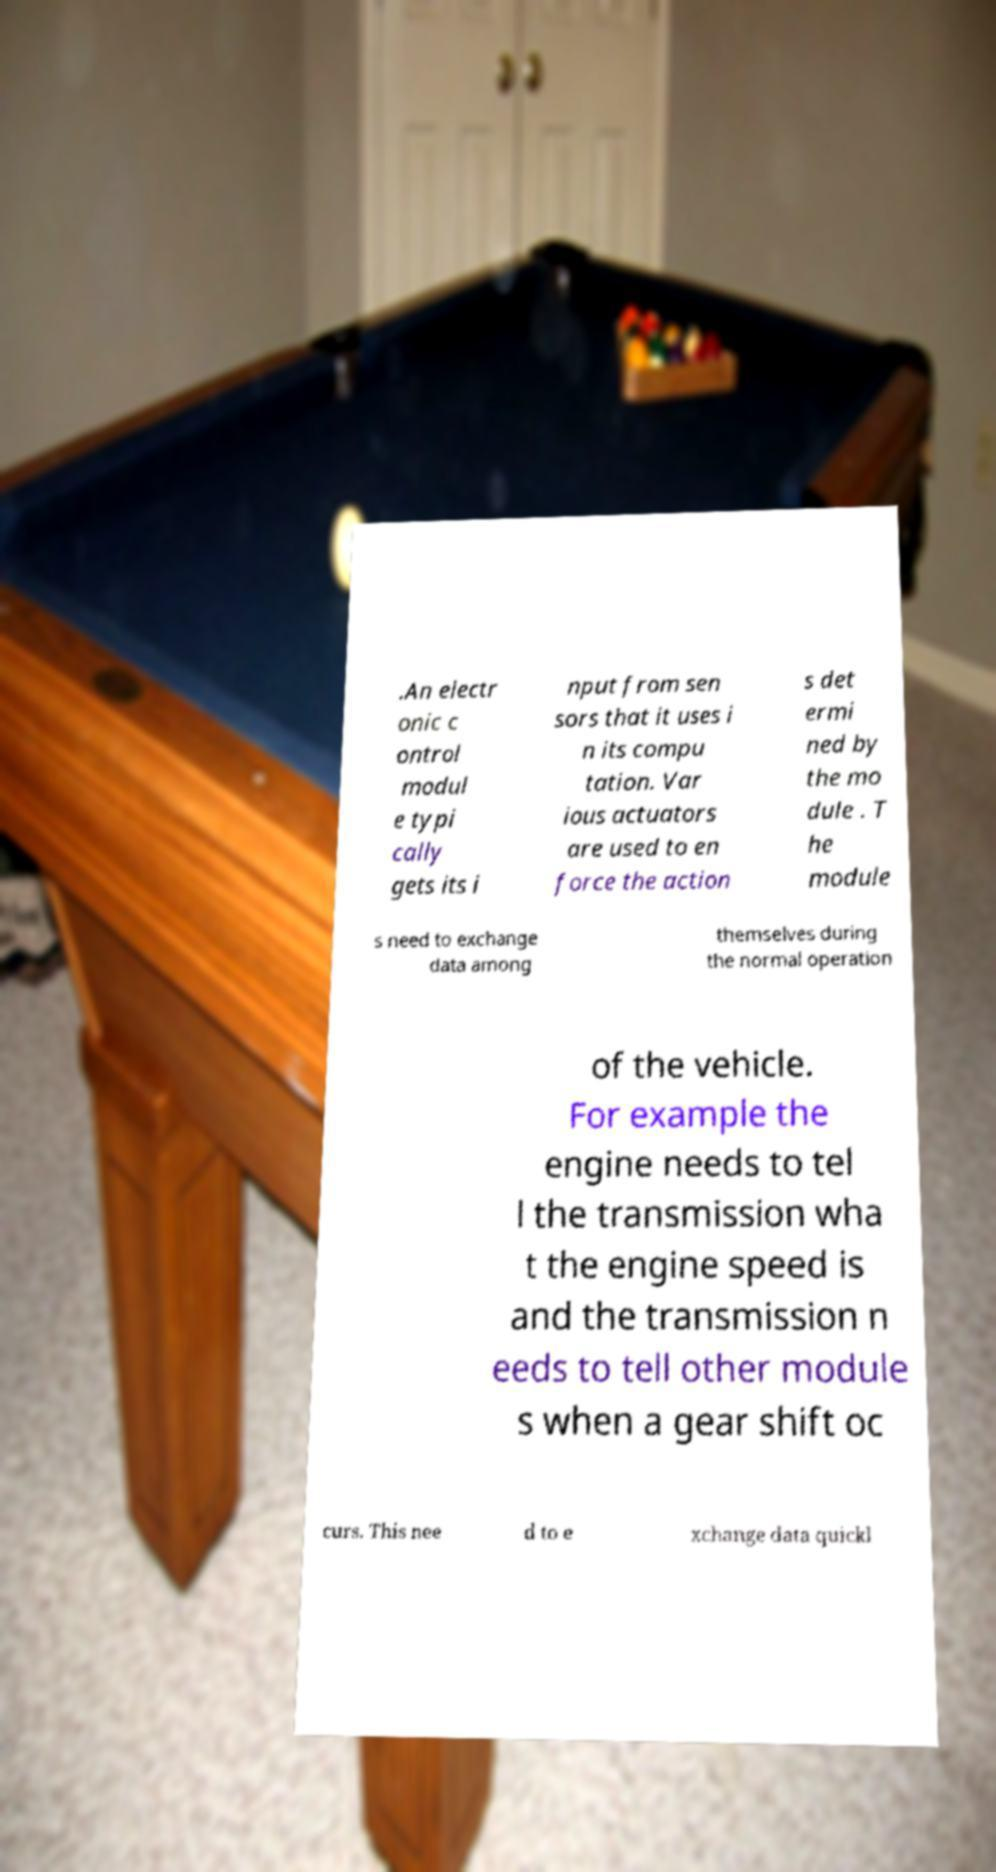Please read and relay the text visible in this image. What does it say? .An electr onic c ontrol modul e typi cally gets its i nput from sen sors that it uses i n its compu tation. Var ious actuators are used to en force the action s det ermi ned by the mo dule . T he module s need to exchange data among themselves during the normal operation of the vehicle. For example the engine needs to tel l the transmission wha t the engine speed is and the transmission n eeds to tell other module s when a gear shift oc curs. This nee d to e xchange data quickl 